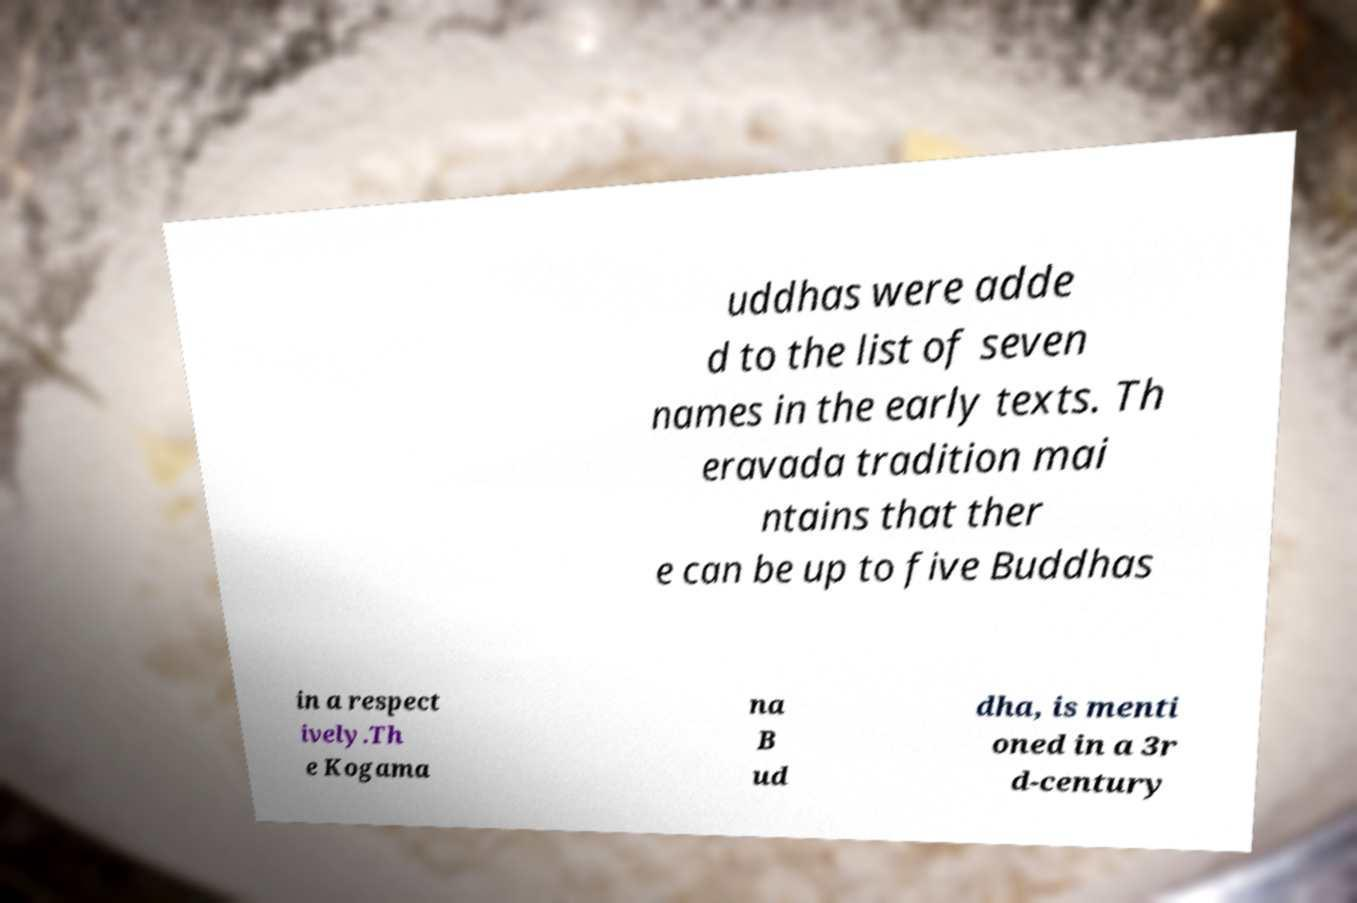Please identify and transcribe the text found in this image. uddhas were adde d to the list of seven names in the early texts. Th eravada tradition mai ntains that ther e can be up to five Buddhas in a respect ively.Th e Kogama na B ud dha, is menti oned in a 3r d-century 